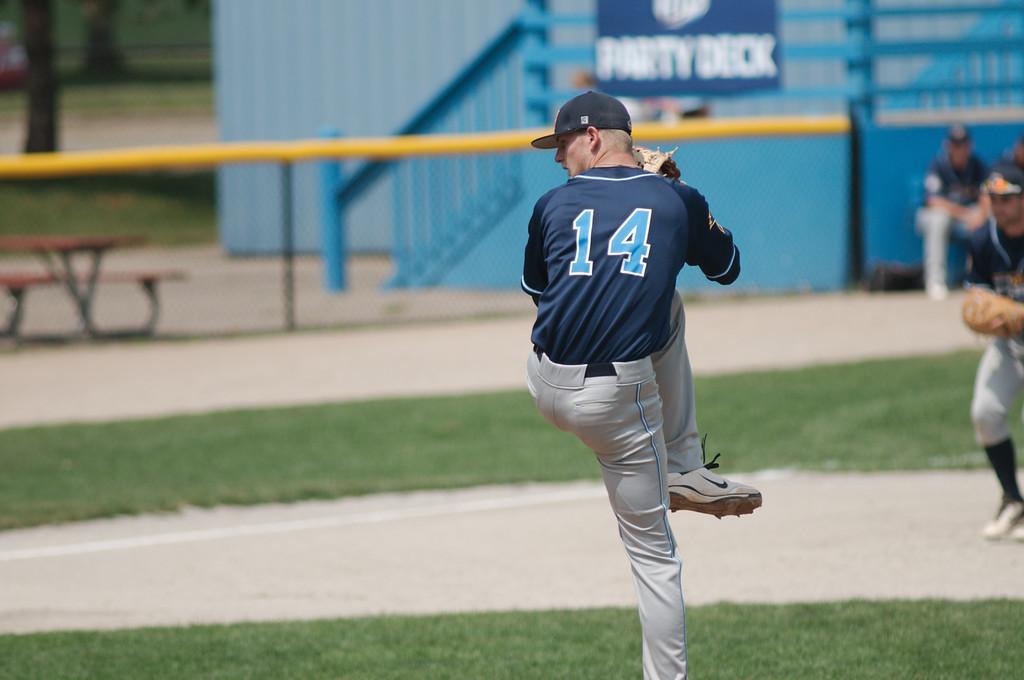How would you summarize this image in a sentence or two? Front we can see a man. Background it is blur. We can see grass, bench and people. 